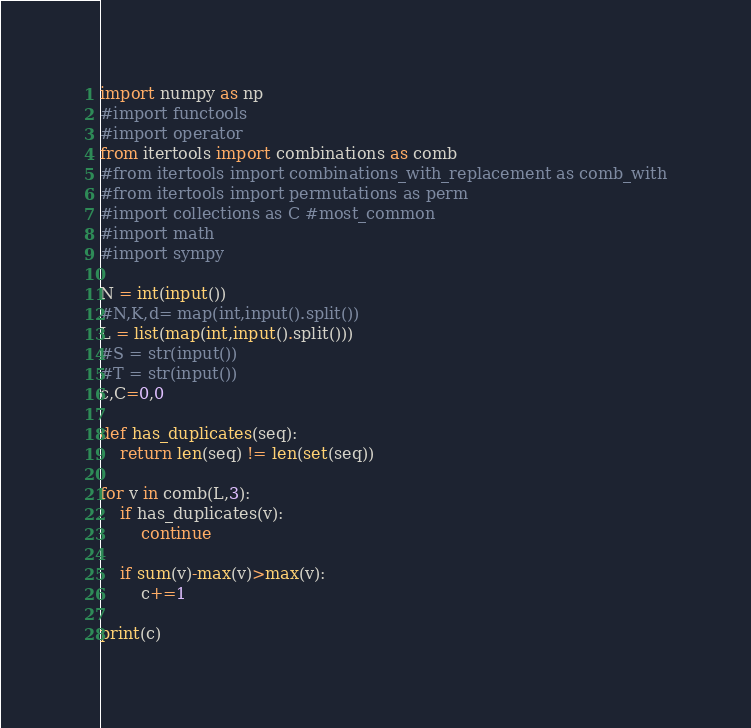Convert code to text. <code><loc_0><loc_0><loc_500><loc_500><_Python_>import numpy as np
#import functools
#import operator
from itertools import combinations as comb
#from itertools import combinations_with_replacement as comb_with
#from itertools import permutations as perm
#import collections as C #most_common
#import math
#import sympy

N = int(input())
#N,K,d= map(int,input().split())
L = list(map(int,input().split()))
#S = str(input())
#T = str(input())
c,C=0,0

def has_duplicates(seq):
    return len(seq) != len(set(seq))

for v in comb(L,3):
    if has_duplicates(v):
        continue

    if sum(v)-max(v)>max(v):
        c+=1

print(c)
</code> 